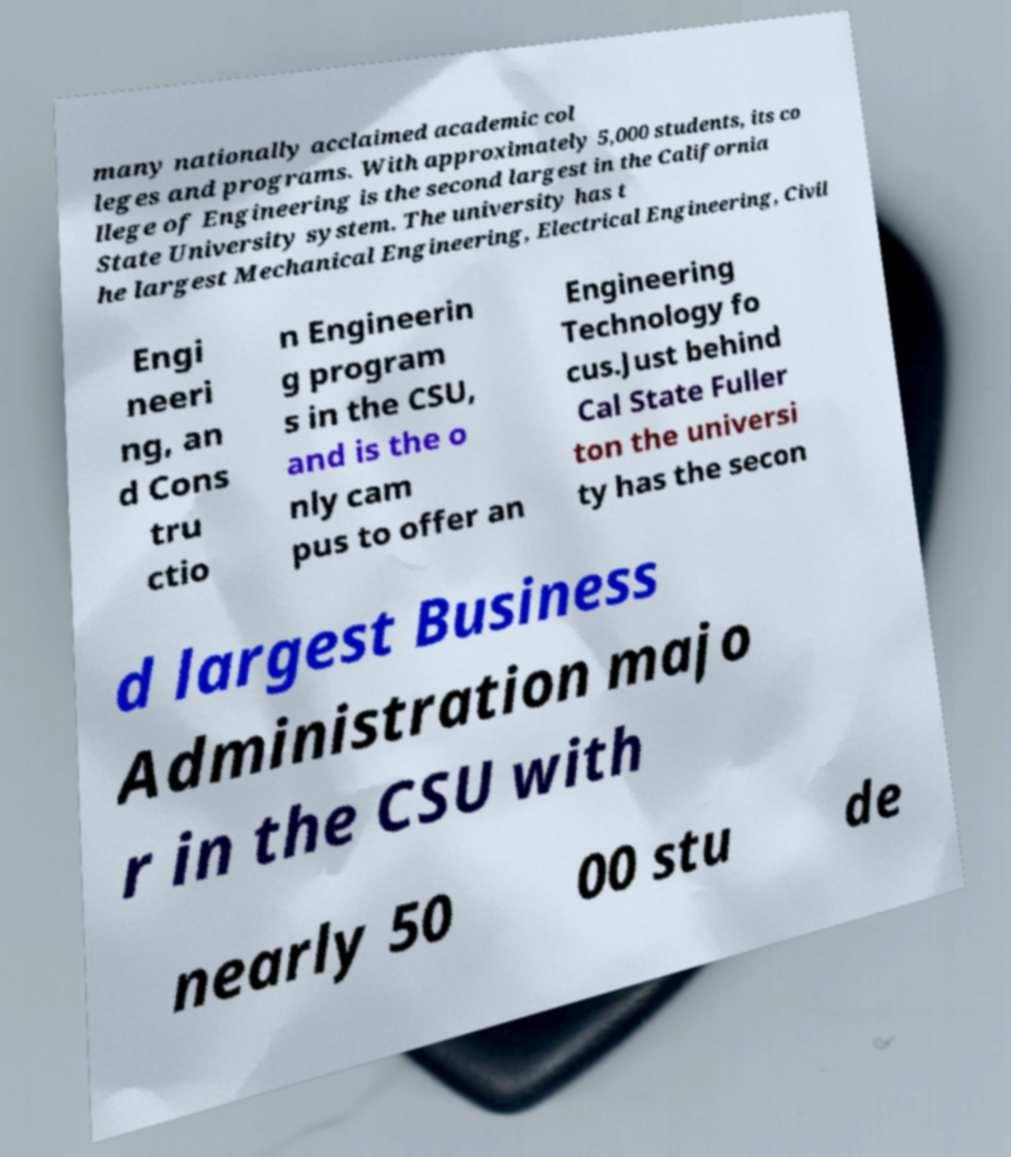Can you read and provide the text displayed in the image?This photo seems to have some interesting text. Can you extract and type it out for me? many nationally acclaimed academic col leges and programs. With approximately 5,000 students, its co llege of Engineering is the second largest in the California State University system. The university has t he largest Mechanical Engineering, Electrical Engineering, Civil Engi neeri ng, an d Cons tru ctio n Engineerin g program s in the CSU, and is the o nly cam pus to offer an Engineering Technology fo cus.Just behind Cal State Fuller ton the universi ty has the secon d largest Business Administration majo r in the CSU with nearly 50 00 stu de 